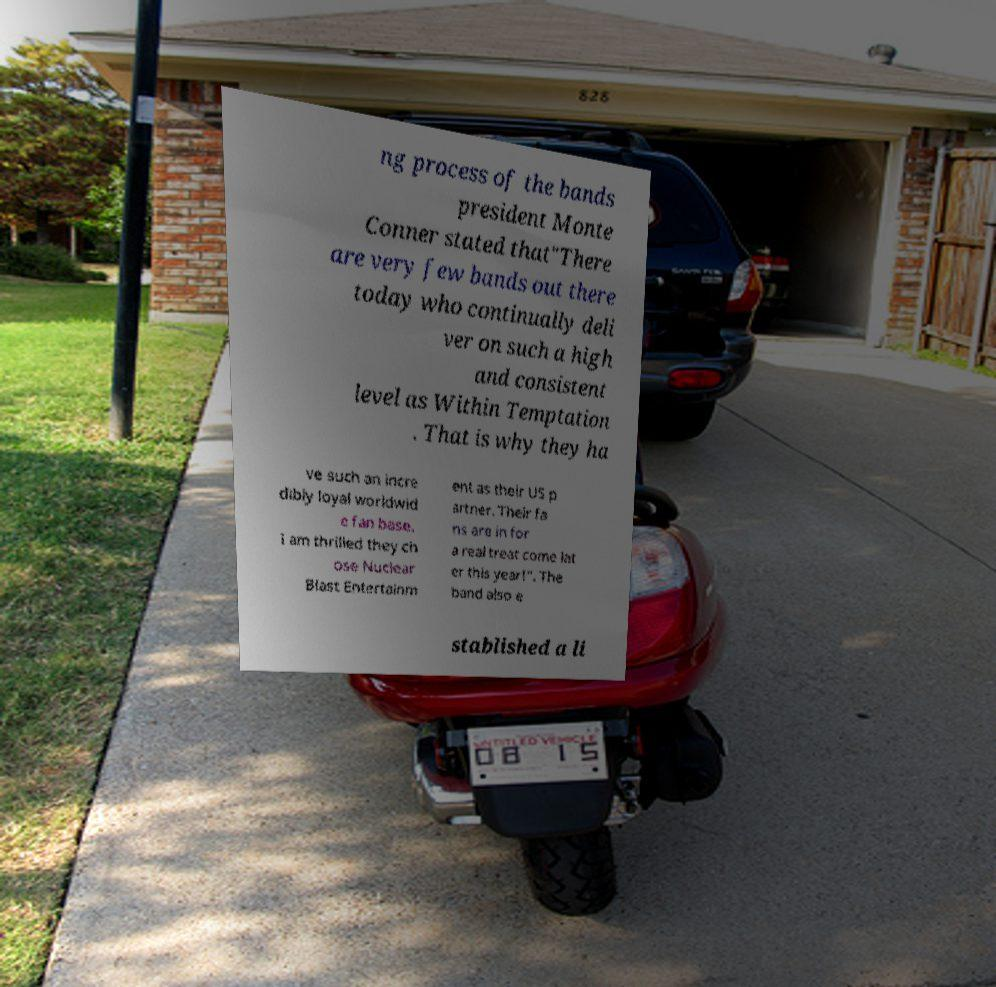Can you accurately transcribe the text from the provided image for me? ng process of the bands president Monte Conner stated that"There are very few bands out there today who continually deli ver on such a high and consistent level as Within Temptation . That is why they ha ve such an incre dibly loyal worldwid e fan base. I am thrilled they ch ose Nuclear Blast Entertainm ent as their US p artner. Their fa ns are in for a real treat come lat er this year!". The band also e stablished a li 